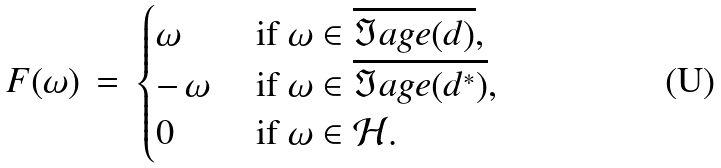Convert formula to latex. <formula><loc_0><loc_0><loc_500><loc_500>F ( \omega ) \, = \, \begin{cases} \omega & \text { if } \omega \in \overline { \Im a g e ( d ) } , \\ - \, \omega & \text { if } \omega \in \overline { \Im a g e ( d ^ { * } ) } , \\ 0 & \text { if } \omega \in { \mathcal { H } } . \end{cases}</formula> 